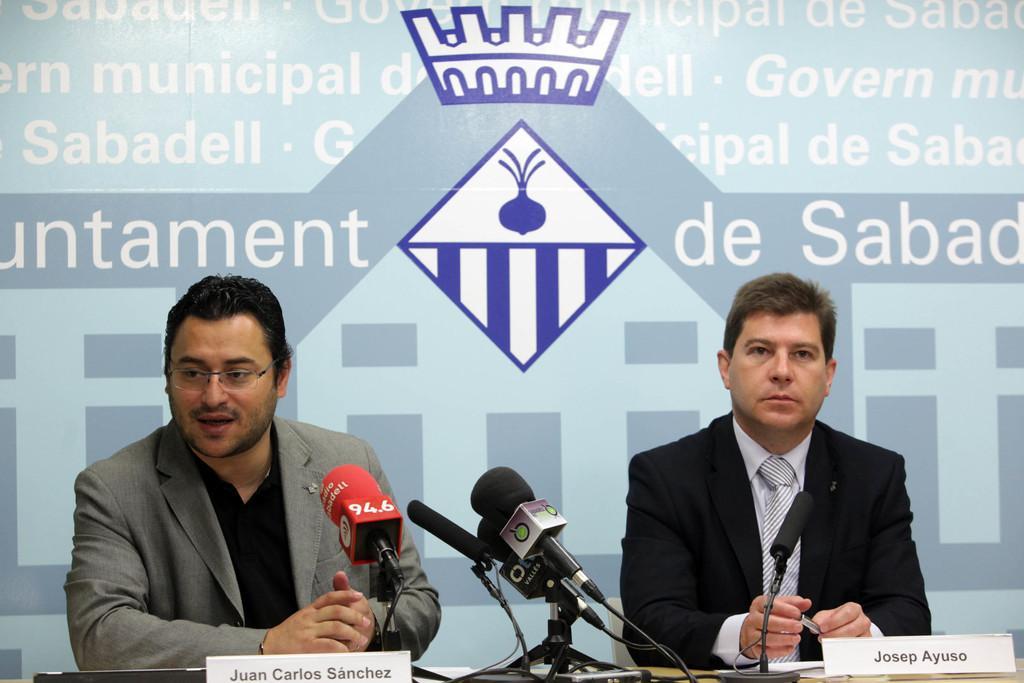Please provide a concise description of this image. In the background we can see a banner. In this picture we can see the men wearing blazers. On a table we can see name boards, microphones. On the left side of the picture we can see a person is wearing spectacles and he is talking. 